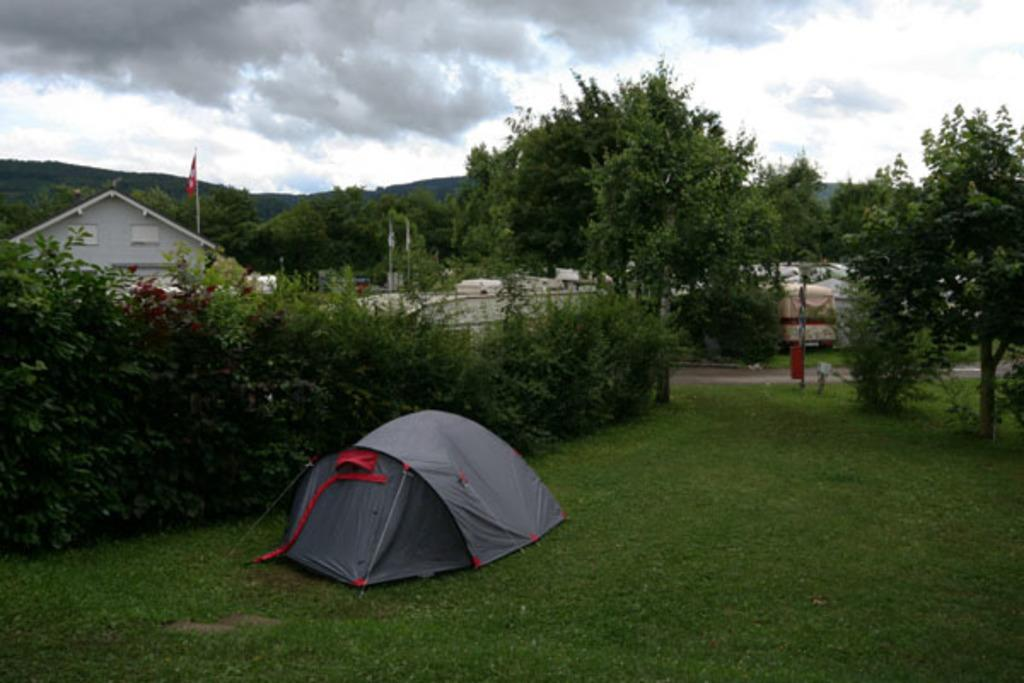What type of vegetation can be seen in the image? There are plants and grass in the image. What type of structure is visible in the image? There is a building in the image. What type of pathway is present in the image? There is a road in the image. What type of natural scenery is visible in the backdrop of the image? There are trees in the backdrop of the image. What is the condition of the sky in the image? The sky is clear in the image. Can you tell me how the crook is using magic to manipulate the current in the image? There is no crook, magic, or current present in the image. 